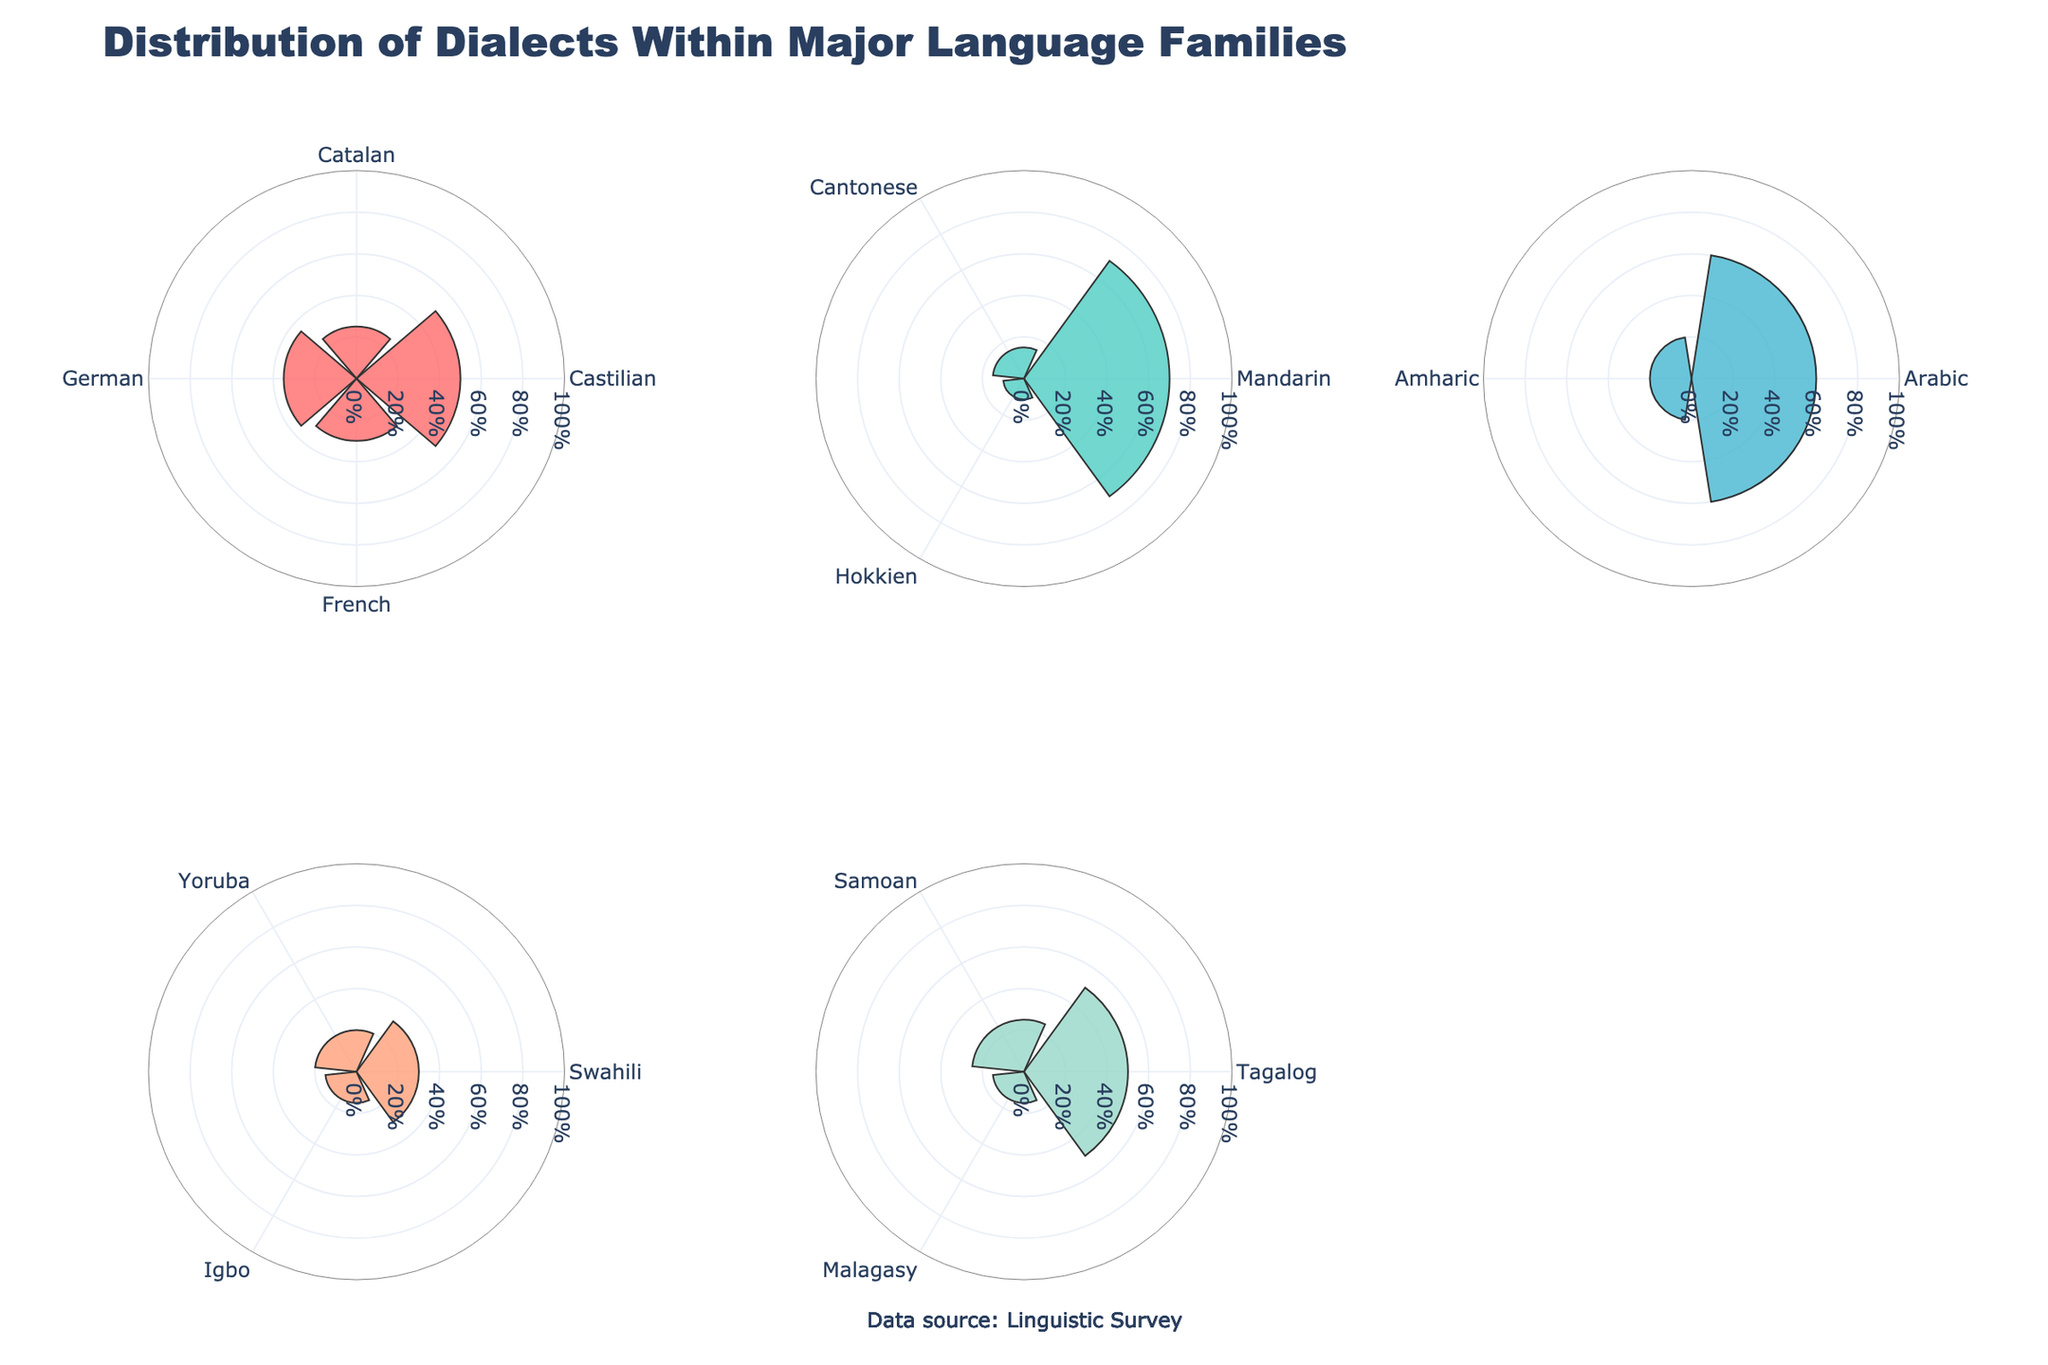What is the title of the figure? The title of the figure is typically found at the top and often provides a summary of what the figure represents. In this case, the title is "Distribution of Dialects Within Major Language Families."
Answer: Distribution of Dialects Within Major Language Families How many subplots are there in the figure? The figure is divided into multiple sections, each representing a language family. The code indicates that there are 2 rows and 3 columns, making a total of 6 subplots.
Answer: 6 Which dialect has the highest percentage in the Sino-Tibetan language family? By looking at the Sino-Tibetan subplot, we see that Mandarin has the largest slice, indicating it has the highest percentage.
Answer: Mandarin What percentage of dialects within the Indo-European language family does Castilian represent? In the Indo-European subplot, Castilian's slice size shows it represents 50% of the dialects within this language family.
Answer: 50% Compare the distribution of dialects between the Niger-Congo and Austronesian language families. Which dialects have the same percentage between the two families? By comparing the distributions in the Niger-Congo and Austronesian subplots, we see that Swahili in Niger-Congo and Tagalog in Austronesian both represent 30%.
Answer: Swahili and Tagalog What is the total percentage of dialects represented by Yoruba and Igbo in the Niger-Congo language family? Yoruba has 20% and Igbo has 15%. Adding them together gives 20% + 15% = 35%.
Answer: 35% Which language family has the most evenly distributed dialect percentages? An evenly distributed language family would have slices of similar sizes. By comparing all language families, we notice that Indo-European has relatively even distribution with Castilian (50%), Catalan (25%), German (35%), and French (30%).
Answer: Indo-European What region is associated with the highest percentage dialect in the Sino-Tibetan language family? Mandarin is the highest percentage dialect in the Sino-Tibetan family. According to the data, Mandarin is associated with China.
Answer: China 